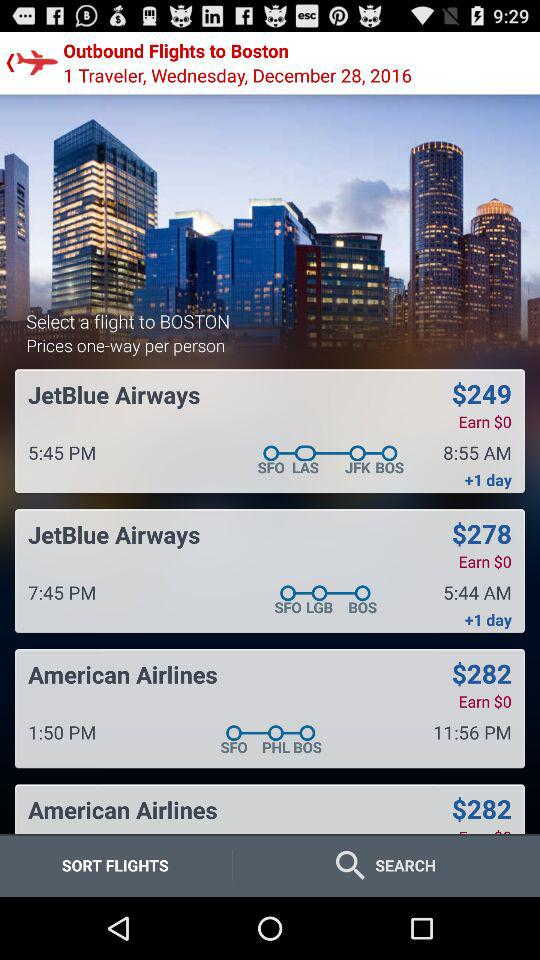For what date have the flight tickets been searched? The flight tickets have been searched for Wednesday, December 28, 2016. 